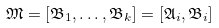<formula> <loc_0><loc_0><loc_500><loc_500>\mathfrak { M } = [ \mathfrak { B } _ { 1 } , \dots , \mathfrak { B } _ { k } ] = [ \mathfrak { A } _ { i } , \mathfrak { B } _ { i } ]</formula> 